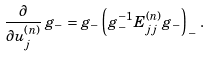Convert formula to latex. <formula><loc_0><loc_0><loc_500><loc_500>\frac { \partial } { \partial u ^ { ( n ) } _ { j } } \, g _ { - } = g _ { - } \left ( g _ { - } ^ { - 1 } E ^ { ( n ) } _ { j j } g _ { - } \right ) _ { - } \, .</formula> 